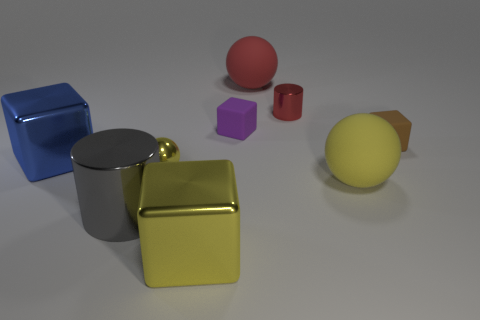Subtract all cylinders. How many objects are left? 7 Subtract all large red rubber things. Subtract all yellow metallic balls. How many objects are left? 7 Add 3 small rubber objects. How many small rubber objects are left? 5 Add 6 large metal cylinders. How many large metal cylinders exist? 7 Subtract 0 cyan balls. How many objects are left? 9 